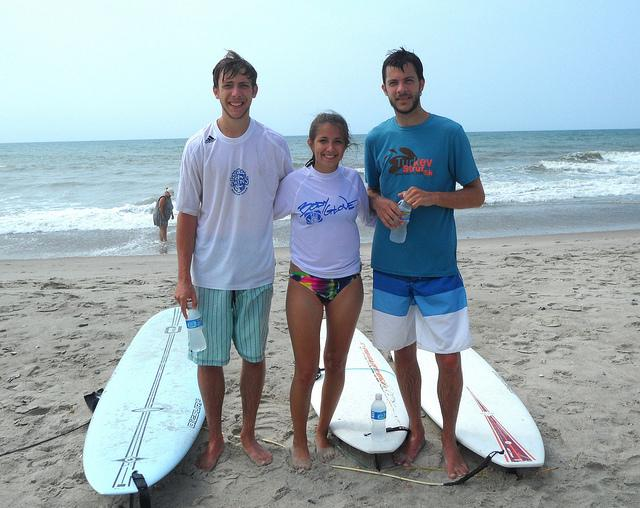How many types of surfboards are there? three 